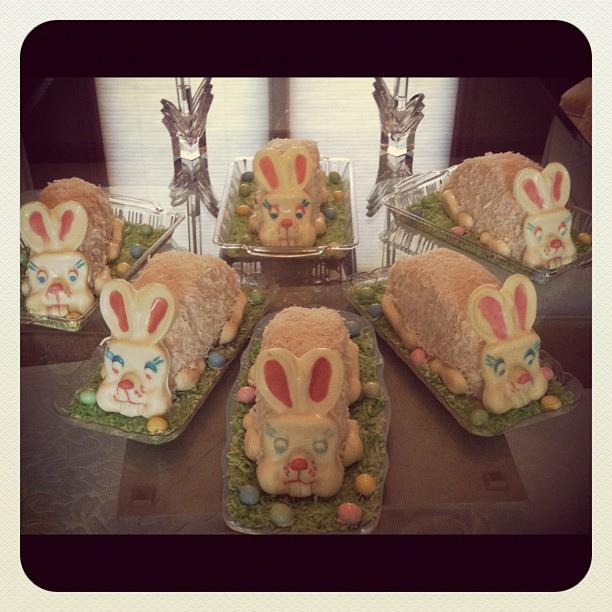What kind of food is this?
Be succinct. Cake. Are there any apples on the table?
Concise answer only. No. What color are the inside of the bunny ears?
Short answer required. Pink. What holiday are these people getting ready to celebrate?
Short answer required. Easter. 